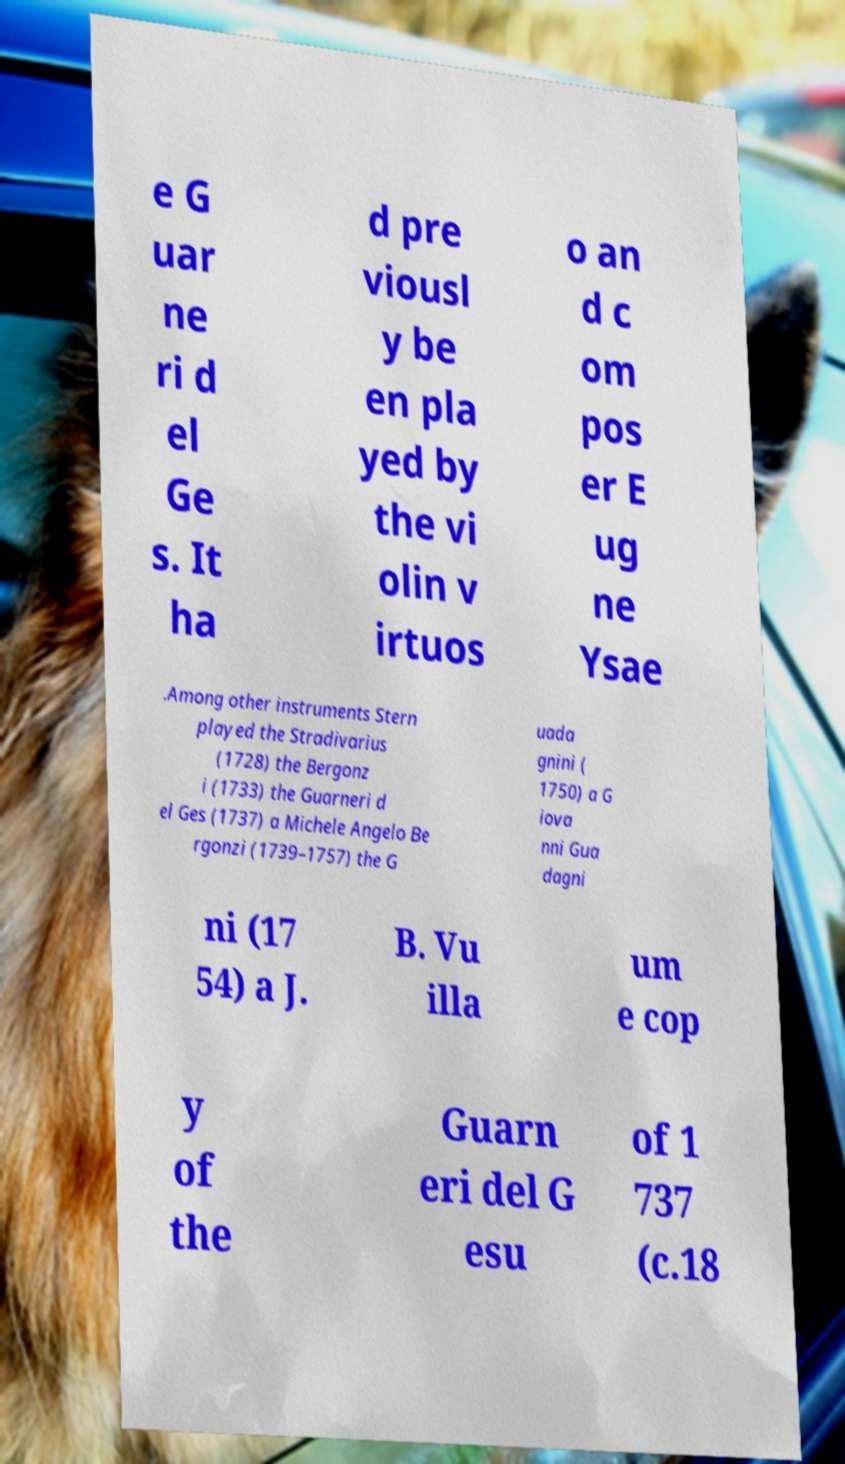Please identify and transcribe the text found in this image. e G uar ne ri d el Ge s. It ha d pre viousl y be en pla yed by the vi olin v irtuos o an d c om pos er E ug ne Ysae .Among other instruments Stern played the Stradivarius (1728) the Bergonz i (1733) the Guarneri d el Ges (1737) a Michele Angelo Be rgonzi (1739–1757) the G uada gnini ( 1750) a G iova nni Gua dagni ni (17 54) a J. B. Vu illa um e cop y of the Guarn eri del G esu of 1 737 (c.18 